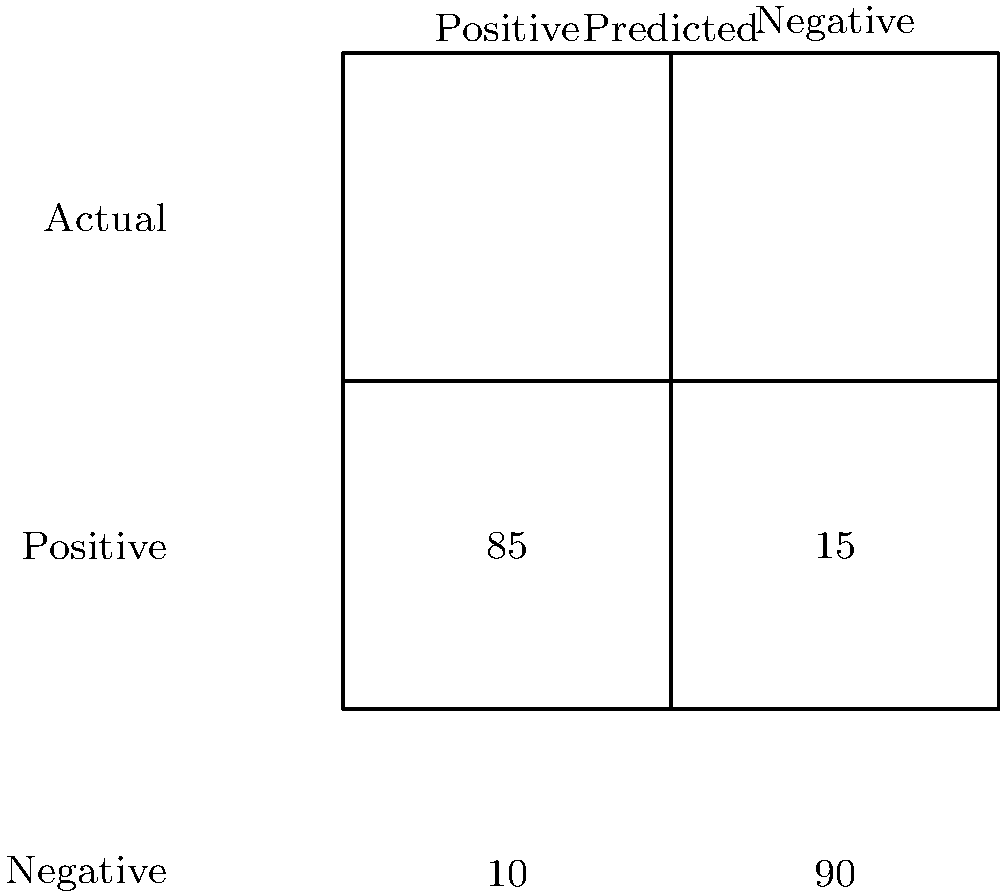As part of your role in overseeing individuals released from incarceration, you're evaluating a facial recognition system for monitoring. Given the confusion matrix above for the system's performance on a test set of 200 images, what is the system's accuracy? To calculate the accuracy of the facial recognition system, we need to follow these steps:

1. Understand the confusion matrix:
   - True Positives (TP): 85 (correctly identified as positive)
   - False Negatives (FN): 15 (incorrectly identified as negative)
   - False Positives (FP): 10 (incorrectly identified as positive)
   - True Negatives (TN): 90 (correctly identified as negative)

2. Calculate the total number of predictions:
   Total = TP + FN + FP + TN = 85 + 15 + 10 + 90 = 200

3. Calculate the number of correct predictions:
   Correct predictions = TP + TN = 85 + 90 = 175

4. Calculate the accuracy using the formula:
   $$ \text{Accuracy} = \frac{\text{Number of correct predictions}}{\text{Total number of predictions}} $$

5. Plug in the values:
   $$ \text{Accuracy} = \frac{175}{200} = 0.875 $$

6. Convert to percentage:
   0.875 * 100 = 87.5%

Therefore, the accuracy of the facial recognition system is 87.5%.
Answer: 87.5% 